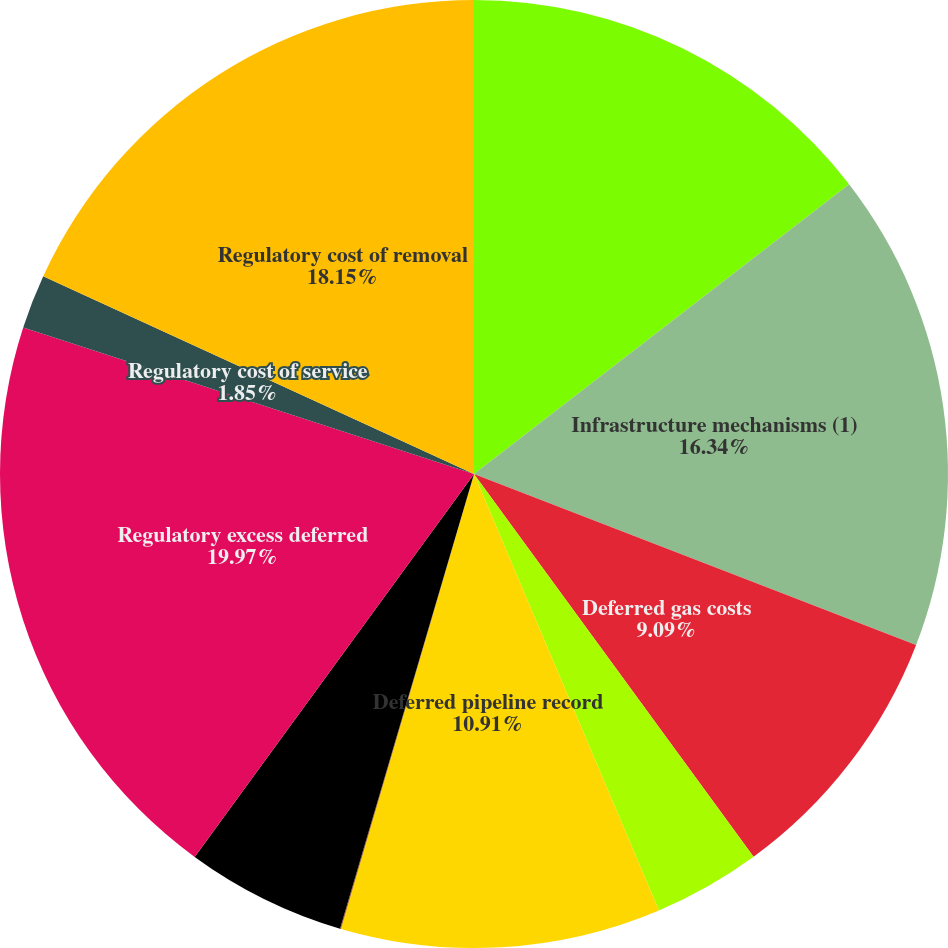Convert chart to OTSL. <chart><loc_0><loc_0><loc_500><loc_500><pie_chart><fcel>Pension and postretirement<fcel>Infrastructure mechanisms (1)<fcel>Deferred gas costs<fcel>Recoverable loss on reacquired<fcel>Deferred pipeline record<fcel>Rate case costs<fcel>Other<fcel>Regulatory excess deferred<fcel>Regulatory cost of service<fcel>Regulatory cost of removal<nl><fcel>14.53%<fcel>16.34%<fcel>9.09%<fcel>3.66%<fcel>10.91%<fcel>0.03%<fcel>5.47%<fcel>19.97%<fcel>1.85%<fcel>18.15%<nl></chart> 